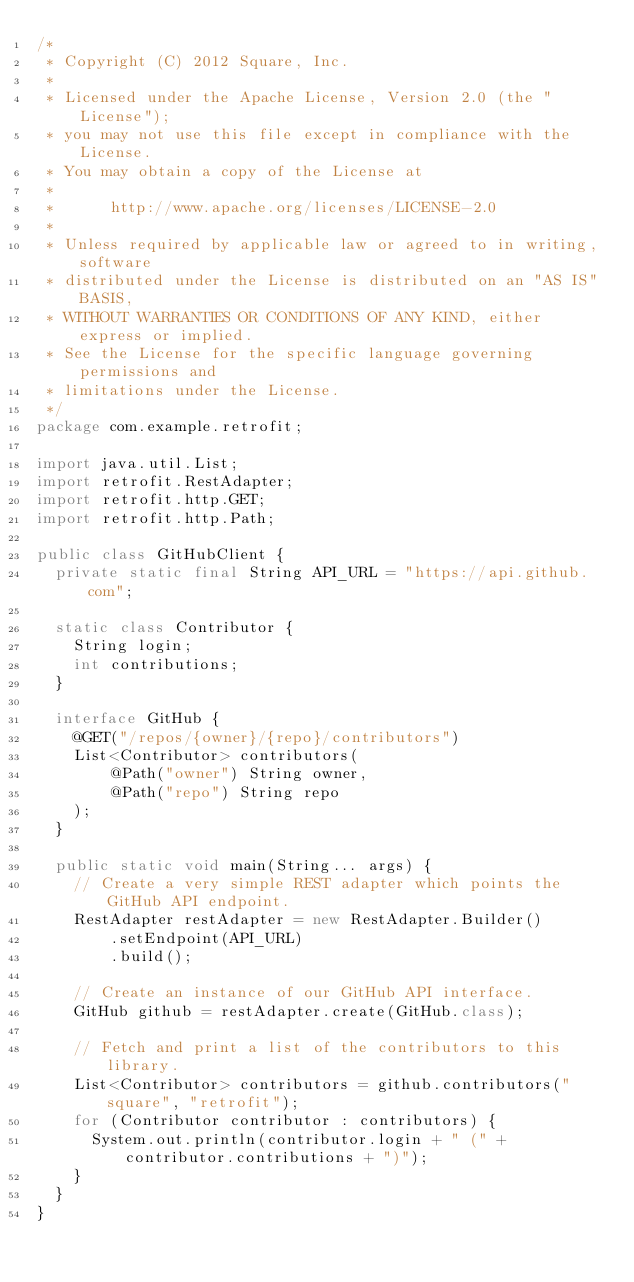<code> <loc_0><loc_0><loc_500><loc_500><_Java_>/*
 * Copyright (C) 2012 Square, Inc.
 *
 * Licensed under the Apache License, Version 2.0 (the "License");
 * you may not use this file except in compliance with the License.
 * You may obtain a copy of the License at
 *
 *      http://www.apache.org/licenses/LICENSE-2.0
 *
 * Unless required by applicable law or agreed to in writing, software
 * distributed under the License is distributed on an "AS IS" BASIS,
 * WITHOUT WARRANTIES OR CONDITIONS OF ANY KIND, either express or implied.
 * See the License for the specific language governing permissions and
 * limitations under the License.
 */
package com.example.retrofit;

import java.util.List;
import retrofit.RestAdapter;
import retrofit.http.GET;
import retrofit.http.Path;

public class GitHubClient {
  private static final String API_URL = "https://api.github.com";

  static class Contributor {
    String login;
    int contributions;
  }

  interface GitHub {
    @GET("/repos/{owner}/{repo}/contributors")
    List<Contributor> contributors(
        @Path("owner") String owner,
        @Path("repo") String repo
    );
  }

  public static void main(String... args) {
    // Create a very simple REST adapter which points the GitHub API endpoint.
    RestAdapter restAdapter = new RestAdapter.Builder()
        .setEndpoint(API_URL)
        .build();

    // Create an instance of our GitHub API interface.
    GitHub github = restAdapter.create(GitHub.class);

    // Fetch and print a list of the contributors to this library.
    List<Contributor> contributors = github.contributors("square", "retrofit");
    for (Contributor contributor : contributors) {
      System.out.println(contributor.login + " (" + contributor.contributions + ")");
    }
  }
}
</code> 